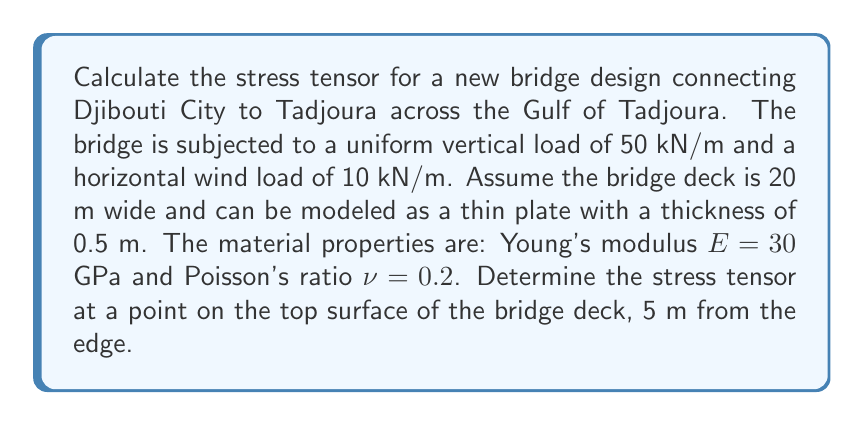What is the answer to this math problem? To calculate the stress tensor for the bridge design, we'll follow these steps:

1) First, we need to determine the stress components. For a thin plate, we can use the plane stress assumption, which means σzz = τxz = τyz = 0.

2) Calculate the normal stresses σxx and σyy:
   The bending moment due to the vertical load:
   $$ M = \frac{wL^2}{8} $$
   where w is the load per unit length and L is the span length.
   
   Assuming a span of 100 m:
   $$ M = \frac{50 \times 100^2}{8} = 62500 \text{ kNm} $$

   The section modulus for a rectangular section:
   $$ Z = \frac{bt^2}{6} = \frac{20 \times 0.5^2}{6} = 0.833 \text{ m}^3 $$

   Normal stress due to bending:
   $$ \sigma_{xx} = \frac{M}{Z} = \frac{62500}{0.833} = 75 \text{ MPa} $$

3) The horizontal wind load will cause a shear stress τxy:
   $$ \tau_{xy} = \frac{VQ}{It} $$
   where V is the shear force, Q is the first moment of area, I is the second moment of area, and t is the thickness.

   $$ V = 10 \times 100 = 1000 \text{ kN} $$
   $$ Q = \frac{bt}{2} \times \frac{t}{4} = \frac{20 \times 0.5}{2} \times \frac{0.5}{4} = 0.625 \text{ m}^3 $$
   $$ I = \frac{bt^3}{12} = \frac{20 \times 0.5^3}{12} = 0.208 \text{ m}^4 $$

   $$ \tau_{xy} = \frac{1000 \times 0.625}{0.208 \times 0.5} = 6 \text{ MPa} $$

4) Due to Poisson's effect:
   $$ \sigma_{yy} = \nu\sigma_{xx} = 0.2 \times 75 = 15 \text{ MPa} $$

5) The stress tensor in matrix form:

   $$ \sigma = \begin{bmatrix} 
   \sigma_{xx} & \tau_{xy} & 0 \\
   \tau_{xy} & \sigma_{yy} & 0 \\
   0 & 0 & 0
   \end{bmatrix} = \begin{bmatrix}
   75 & 6 & 0 \\
   6 & 15 & 0 \\
   0 & 0 & 0
   \end{bmatrix} \text{ MPa} $$
Answer: $$ \sigma = \begin{bmatrix}
75 & 6 & 0 \\
6 & 15 & 0 \\
0 & 0 & 0
\end{bmatrix} \text{ MPa} $$ 